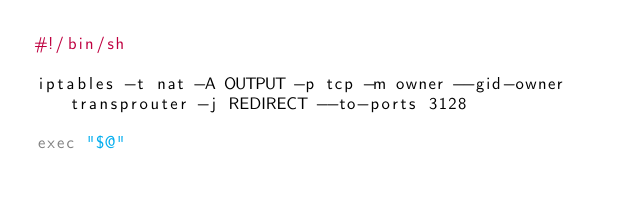Convert code to text. <code><loc_0><loc_0><loc_500><loc_500><_Bash_>#!/bin/sh

iptables -t nat -A OUTPUT -p tcp -m owner --gid-owner transprouter -j REDIRECT --to-ports 3128

exec "$@"
</code> 